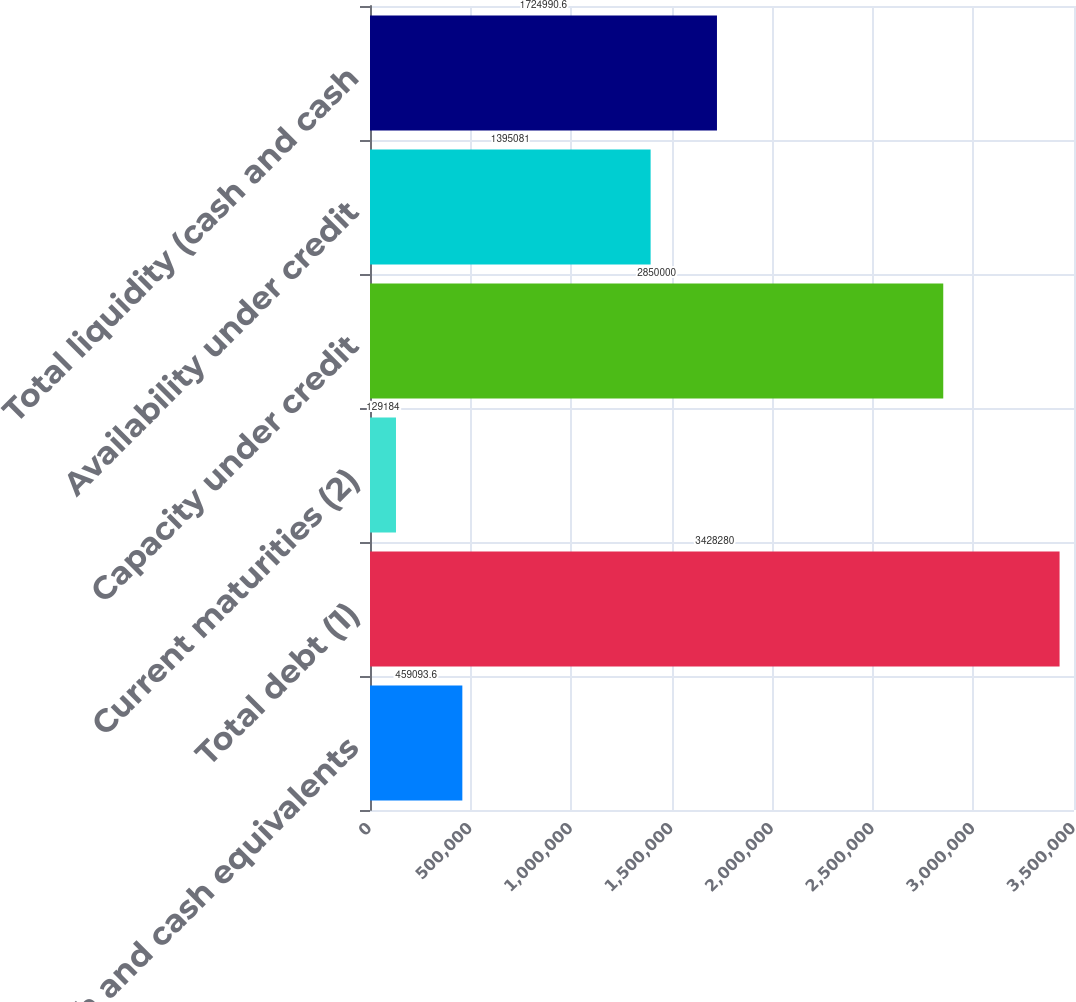<chart> <loc_0><loc_0><loc_500><loc_500><bar_chart><fcel>Cash and cash equivalents<fcel>Total debt (1)<fcel>Current maturities (2)<fcel>Capacity under credit<fcel>Availability under credit<fcel>Total liquidity (cash and cash<nl><fcel>459094<fcel>3.42828e+06<fcel>129184<fcel>2.85e+06<fcel>1.39508e+06<fcel>1.72499e+06<nl></chart> 